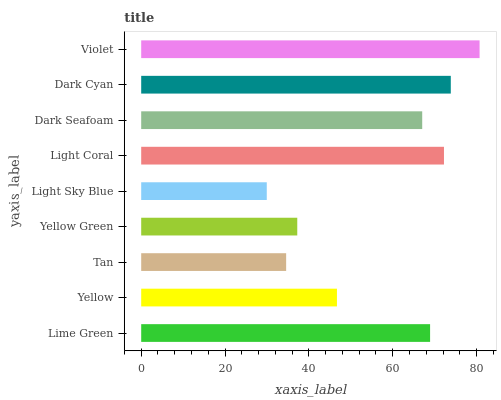Is Light Sky Blue the minimum?
Answer yes or no. Yes. Is Violet the maximum?
Answer yes or no. Yes. Is Yellow the minimum?
Answer yes or no. No. Is Yellow the maximum?
Answer yes or no. No. Is Lime Green greater than Yellow?
Answer yes or no. Yes. Is Yellow less than Lime Green?
Answer yes or no. Yes. Is Yellow greater than Lime Green?
Answer yes or no. No. Is Lime Green less than Yellow?
Answer yes or no. No. Is Dark Seafoam the high median?
Answer yes or no. Yes. Is Dark Seafoam the low median?
Answer yes or no. Yes. Is Light Coral the high median?
Answer yes or no. No. Is Tan the low median?
Answer yes or no. No. 